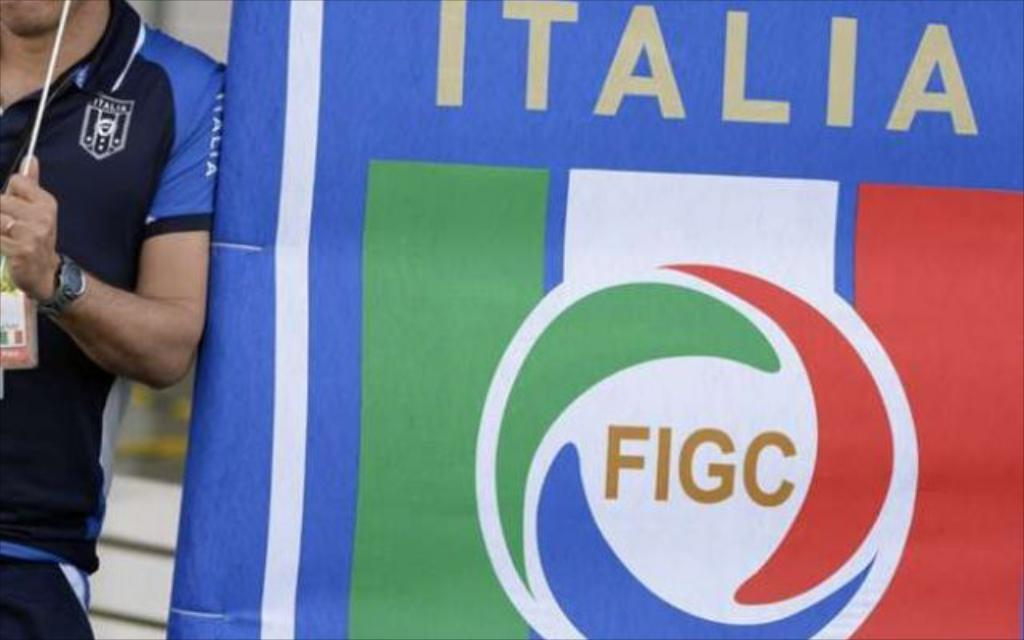<image>
Share a concise interpretation of the image provided. a large blue, green and white banner for FIGC ITALIA 